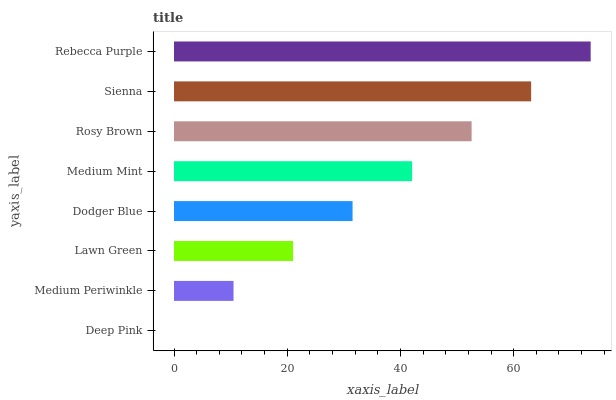Is Deep Pink the minimum?
Answer yes or no. Yes. Is Rebecca Purple the maximum?
Answer yes or no. Yes. Is Medium Periwinkle the minimum?
Answer yes or no. No. Is Medium Periwinkle the maximum?
Answer yes or no. No. Is Medium Periwinkle greater than Deep Pink?
Answer yes or no. Yes. Is Deep Pink less than Medium Periwinkle?
Answer yes or no. Yes. Is Deep Pink greater than Medium Periwinkle?
Answer yes or no. No. Is Medium Periwinkle less than Deep Pink?
Answer yes or no. No. Is Medium Mint the high median?
Answer yes or no. Yes. Is Dodger Blue the low median?
Answer yes or no. Yes. Is Dodger Blue the high median?
Answer yes or no. No. Is Lawn Green the low median?
Answer yes or no. No. 